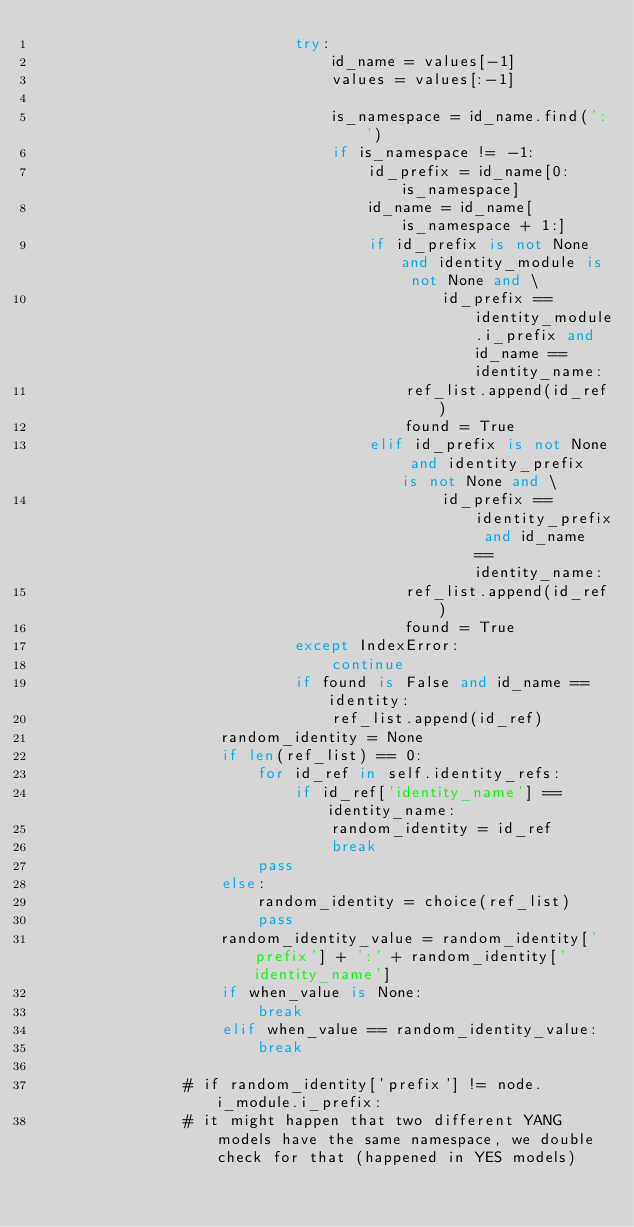Convert code to text. <code><loc_0><loc_0><loc_500><loc_500><_Python_>                            try:
                                id_name = values[-1]
                                values = values[:-1]

                                is_namespace = id_name.find(':')
                                if is_namespace != -1:
                                    id_prefix = id_name[0:is_namespace]
                                    id_name = id_name[is_namespace + 1:]
                                    if id_prefix is not None and identity_module is not None and \
                                            id_prefix == identity_module.i_prefix and id_name == identity_name:
                                        ref_list.append(id_ref)
                                        found = True
                                    elif id_prefix is not None and identity_prefix is not None and \
                                            id_prefix == identity_prefix and id_name == identity_name:
                                        ref_list.append(id_ref)
                                        found = True
                            except IndexError:
                                continue
                            if found is False and id_name == identity:
                                ref_list.append(id_ref)
                    random_identity = None
                    if len(ref_list) == 0:
                        for id_ref in self.identity_refs:
                            if id_ref['identity_name'] == identity_name:
                                random_identity = id_ref
                                break
                        pass
                    else:
                        random_identity = choice(ref_list)
                        pass
                    random_identity_value = random_identity['prefix'] + ':' + random_identity['identity_name']
                    if when_value is None:
                        break
                    elif when_value == random_identity_value:
                        break

                # if random_identity['prefix'] != node.i_module.i_prefix:
                # it might happen that two different YANG models have the same namespace, we double check for that (happened in YES models)</code> 